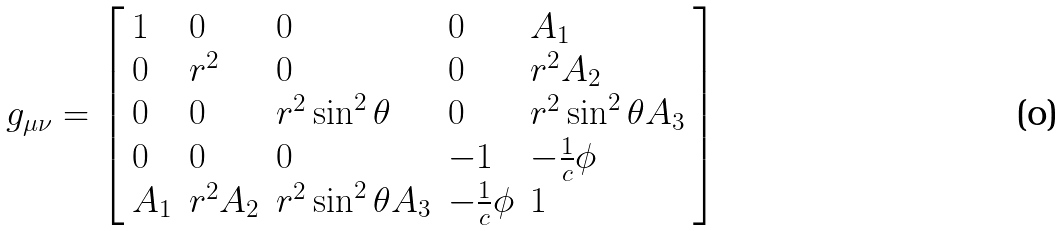<formula> <loc_0><loc_0><loc_500><loc_500>g _ { \mu \nu } = \left [ \begin{array} { l l l l l } 1 & 0 & 0 & 0 & A _ { 1 } \\ 0 & r ^ { 2 } & 0 & 0 & r ^ { 2 } A _ { 2 } \\ 0 & 0 & r ^ { 2 } \sin ^ { 2 } \theta & 0 & r ^ { 2 } \sin ^ { 2 } \theta A _ { 3 } \\ 0 & 0 & 0 & - 1 & - \frac { 1 } { c } \phi \\ A _ { 1 } & r ^ { 2 } A _ { 2 } & r ^ { 2 } \sin ^ { 2 } \theta A _ { 3 } & - \frac { 1 } { c } \phi & 1 \end{array} \right ]</formula> 